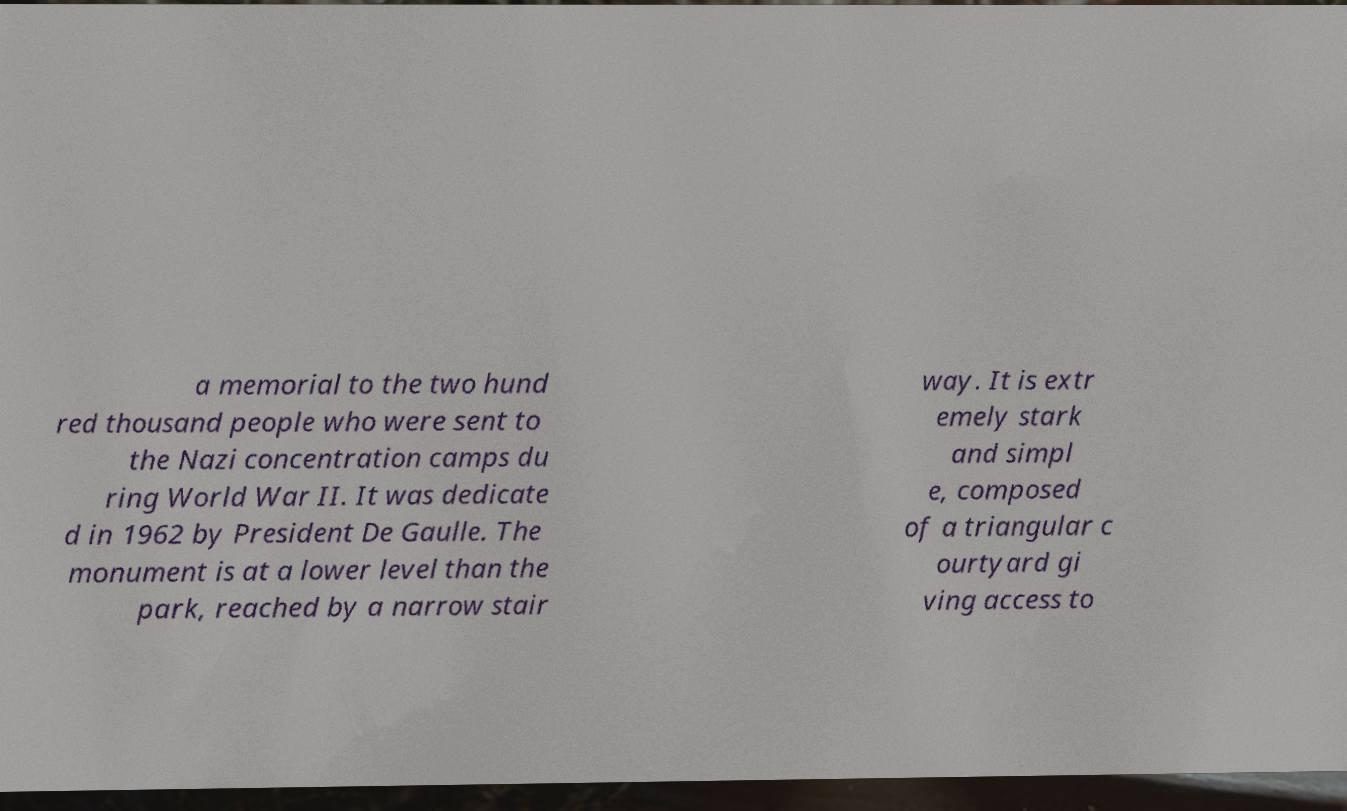Could you assist in decoding the text presented in this image and type it out clearly? a memorial to the two hund red thousand people who were sent to the Nazi concentration camps du ring World War II. It was dedicate d in 1962 by President De Gaulle. The monument is at a lower level than the park, reached by a narrow stair way. It is extr emely stark and simpl e, composed of a triangular c ourtyard gi ving access to 